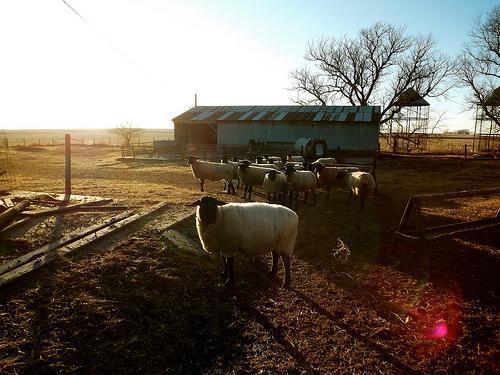How many sheep are not in the bigger group of sheep?
Give a very brief answer. 1. 